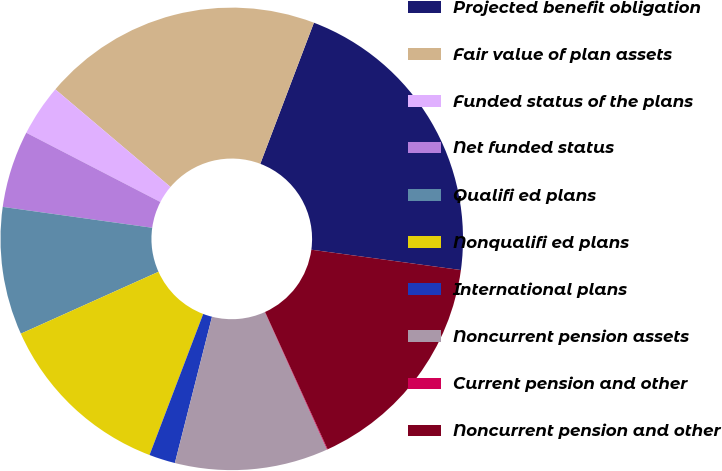Convert chart. <chart><loc_0><loc_0><loc_500><loc_500><pie_chart><fcel>Projected benefit obligation<fcel>Fair value of plan assets<fcel>Funded status of the plans<fcel>Net funded status<fcel>Qualifi ed plans<fcel>Nonqualifi ed plans<fcel>International plans<fcel>Noncurrent pension assets<fcel>Current pension and other<fcel>Noncurrent pension and other<nl><fcel>21.37%<fcel>19.59%<fcel>3.6%<fcel>5.38%<fcel>8.93%<fcel>12.49%<fcel>1.83%<fcel>10.71%<fcel>0.05%<fcel>16.04%<nl></chart> 